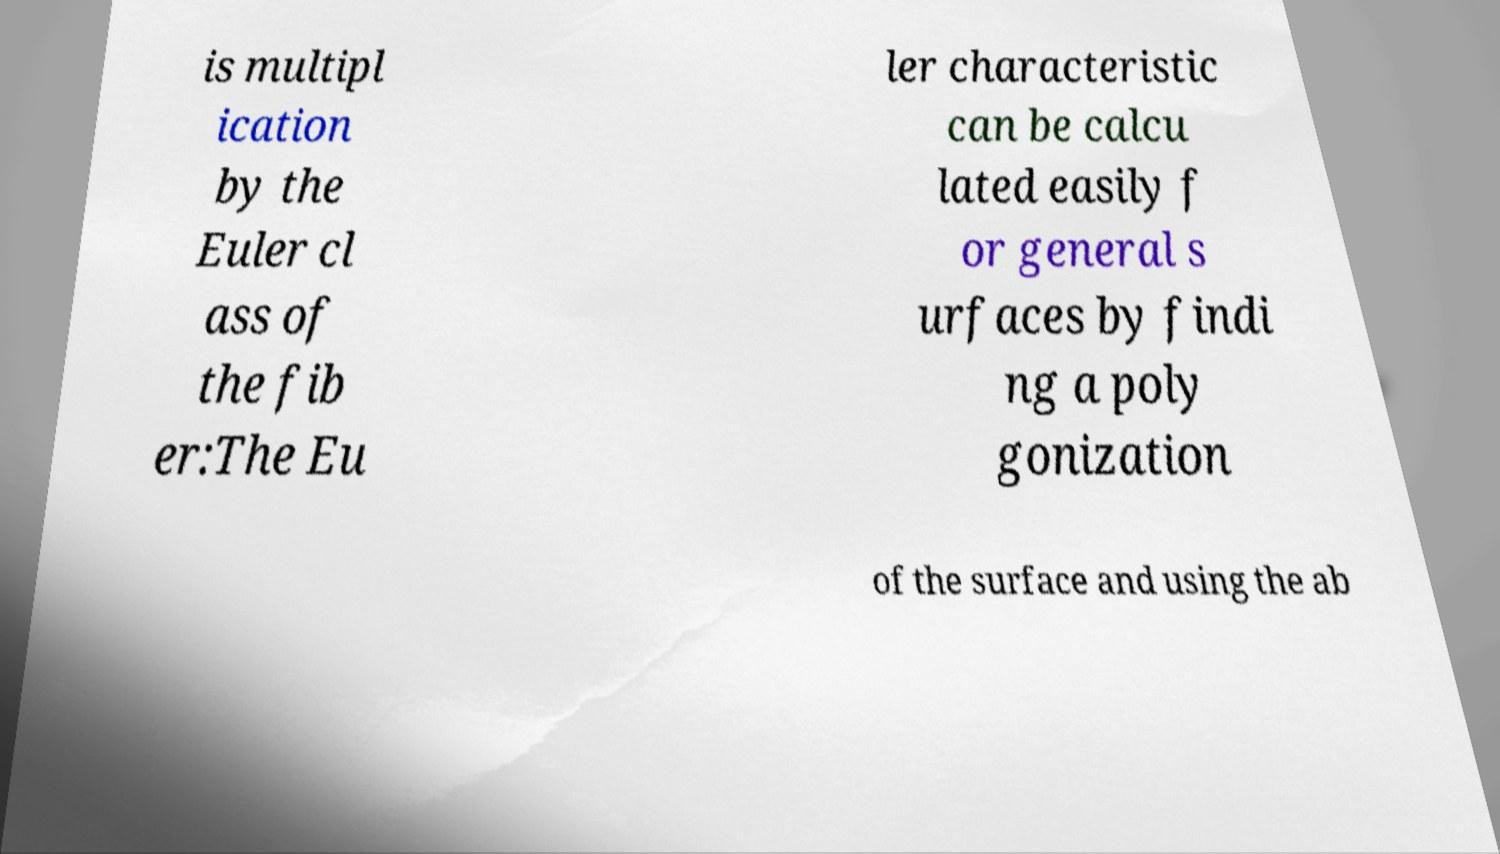Can you read and provide the text displayed in the image?This photo seems to have some interesting text. Can you extract and type it out for me? is multipl ication by the Euler cl ass of the fib er:The Eu ler characteristic can be calcu lated easily f or general s urfaces by findi ng a poly gonization of the surface and using the ab 